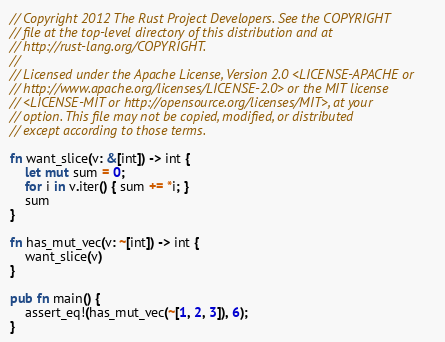<code> <loc_0><loc_0><loc_500><loc_500><_Rust_>// Copyright 2012 The Rust Project Developers. See the COPYRIGHT
// file at the top-level directory of this distribution and at
// http://rust-lang.org/COPYRIGHT.
//
// Licensed under the Apache License, Version 2.0 <LICENSE-APACHE or
// http://www.apache.org/licenses/LICENSE-2.0> or the MIT license
// <LICENSE-MIT or http://opensource.org/licenses/MIT>, at your
// option. This file may not be copied, modified, or distributed
// except according to those terms.

fn want_slice(v: &[int]) -> int {
    let mut sum = 0;
    for i in v.iter() { sum += *i; }
    sum
}

fn has_mut_vec(v: ~[int]) -> int {
    want_slice(v)
}

pub fn main() {
    assert_eq!(has_mut_vec(~[1, 2, 3]), 6);
}
</code> 